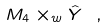<formula> <loc_0><loc_0><loc_500><loc_500>M _ { 4 } \times _ { w } \hat { Y } \ ,</formula> 